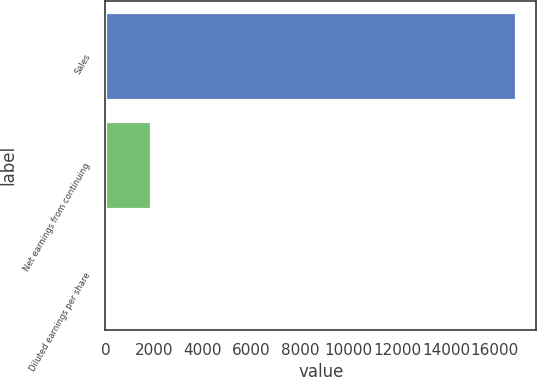Convert chart. <chart><loc_0><loc_0><loc_500><loc_500><bar_chart><fcel>Sales<fcel>Net earnings from continuing<fcel>Diluted earnings per share<nl><fcel>16866.5<fcel>1860.9<fcel>2.66<nl></chart> 